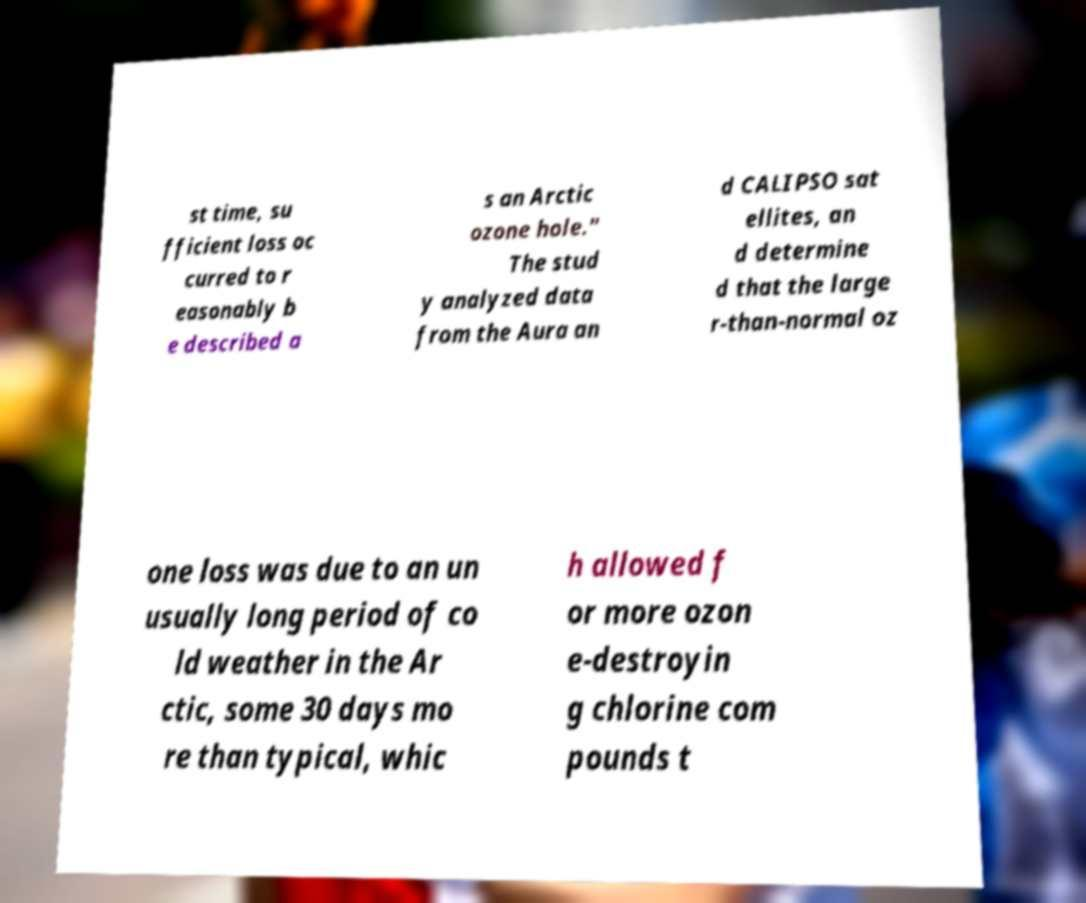There's text embedded in this image that I need extracted. Can you transcribe it verbatim? st time, su fficient loss oc curred to r easonably b e described a s an Arctic ozone hole." The stud y analyzed data from the Aura an d CALIPSO sat ellites, an d determine d that the large r-than-normal oz one loss was due to an un usually long period of co ld weather in the Ar ctic, some 30 days mo re than typical, whic h allowed f or more ozon e-destroyin g chlorine com pounds t 